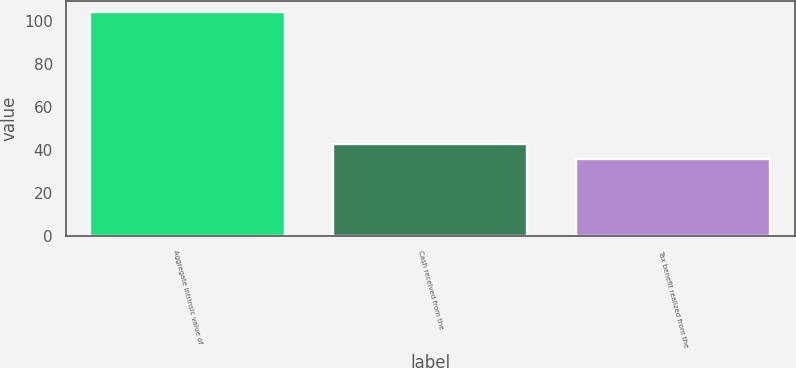Convert chart. <chart><loc_0><loc_0><loc_500><loc_500><bar_chart><fcel>Aggregate intrinsic value of<fcel>Cash received from the<fcel>Tax benefit realized from the<nl><fcel>104<fcel>42.8<fcel>36<nl></chart> 